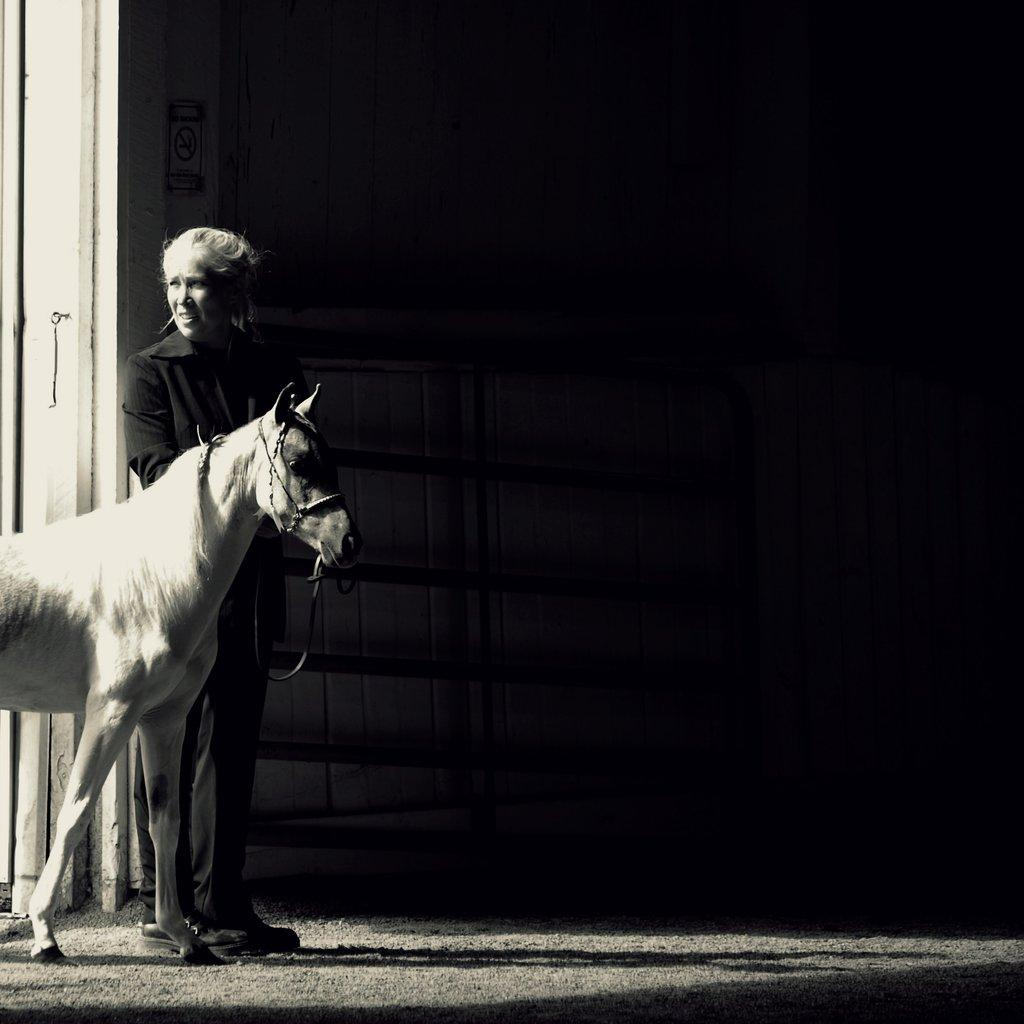Who is the main subject in the image? There is a woman in the image. What is the woman wearing? The woman is wearing a black suit. What is the woman doing in the image? The woman is catching a white horse. How does the woman compare to the feast in the image? There is no feast present in the image, so it is not possible to make a comparison. 